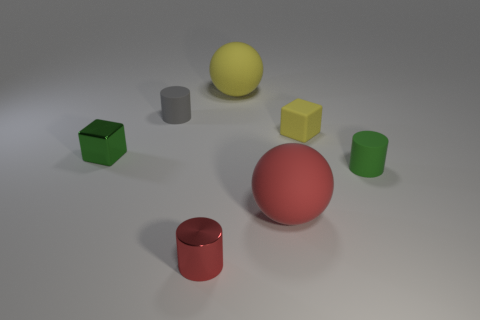Subtract all rubber cylinders. How many cylinders are left? 1 Add 1 small red metallic cylinders. How many objects exist? 8 Subtract all yellow cubes. How many cubes are left? 1 Subtract 1 spheres. How many spheres are left? 1 Subtract all blocks. How many objects are left? 5 Add 4 blocks. How many blocks are left? 6 Add 2 large spheres. How many large spheres exist? 4 Subtract 0 purple spheres. How many objects are left? 7 Subtract all cyan spheres. Subtract all purple cylinders. How many spheres are left? 2 Subtract all big red objects. Subtract all small green rubber things. How many objects are left? 5 